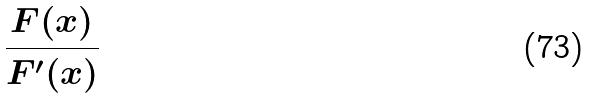Convert formula to latex. <formula><loc_0><loc_0><loc_500><loc_500>\frac { F ( x ) } { F ^ { \prime } ( x ) }</formula> 